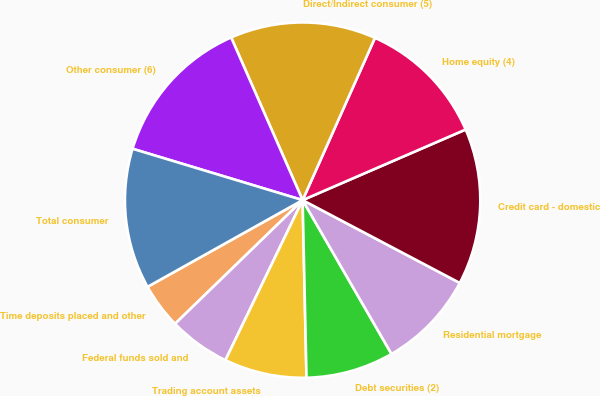<chart> <loc_0><loc_0><loc_500><loc_500><pie_chart><fcel>Time deposits placed and other<fcel>Federal funds sold and<fcel>Trading account assets<fcel>Debt securities (2)<fcel>Residential mortgage<fcel>Credit card - domestic<fcel>Home equity (4)<fcel>Direct/Indirect consumer (5)<fcel>Other consumer (6)<fcel>Total consumer<nl><fcel>4.14%<fcel>5.59%<fcel>7.5%<fcel>7.99%<fcel>8.94%<fcel>14.22%<fcel>11.82%<fcel>13.26%<fcel>13.74%<fcel>12.78%<nl></chart> 